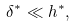Convert formula to latex. <formula><loc_0><loc_0><loc_500><loc_500>\delta ^ { * } \ll h ^ { * } ,</formula> 